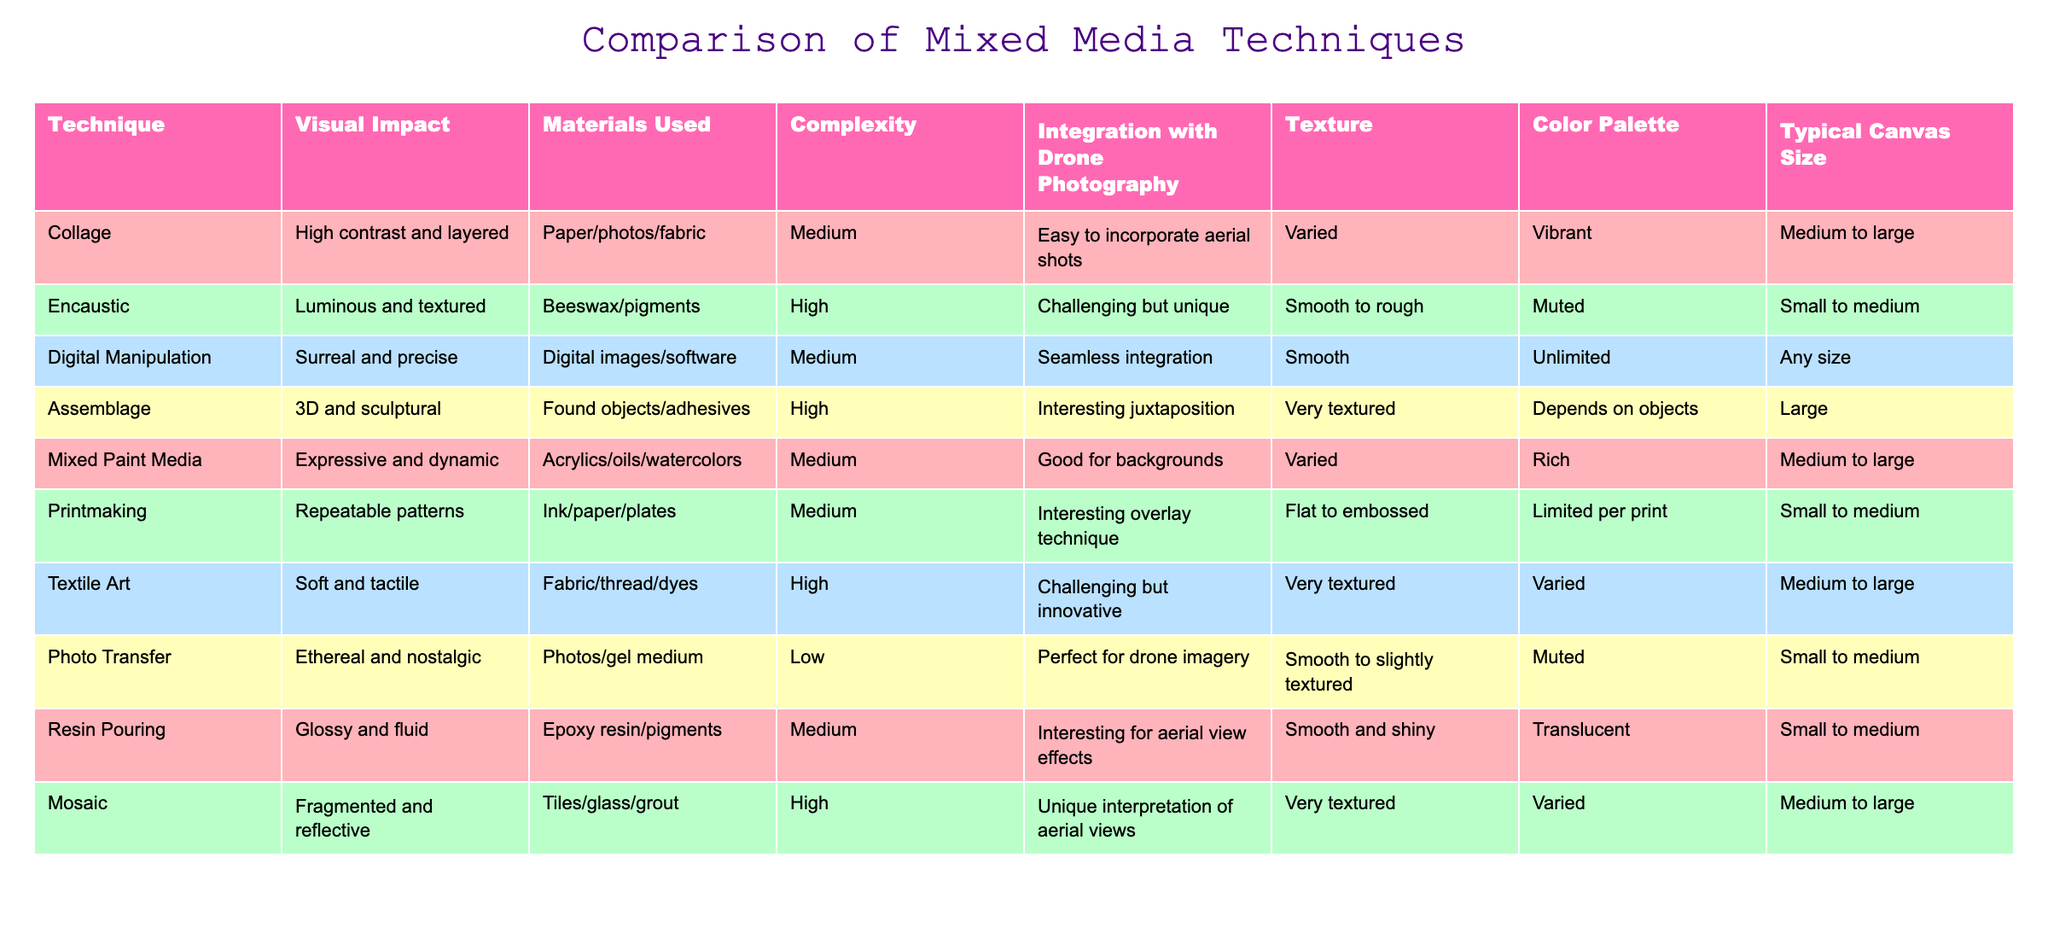What is the complexity level of the Mosaic technique? The table shows the complexity level of each technique. For Mosaic, it is categorized as "High."
Answer: High Which mixed media technique uses digital images and software? The table lists "Digital Manipulation" as the technique that utilizes digital images and software.
Answer: Digital Manipulation How many techniques have a low complexity level? By counting the complexity levels in the table, only the "Photo Transfer" technique is categorized as "Low," making it one technique with this level.
Answer: 1 Is the Textile Art technique easy to integrate with drone photography? The table indicates that Textile Art has a "High" complexity level, suggesting that it is "Challenging but innovative" for drone integration, thus the answer is No.
Answer: No Which two techniques typically have a medium to large canvas size? Referring to the table, "Collage" and "Mixed Paint Media" are noted for having a typical canvas size of medium to large.
Answer: Collage, Mixed Paint Media What is the difference in visual impact between Encaustic and Photo Transfer? Encaustic has a visual impact described as "Luminous and textured," while Photo Transfer has an impact that is "Ethereal and nostalgic." The difference lies in the character of the visual experience they offer.
Answer: Luminous and textured vs. Ethereal and nostalgic How does the texture of Assemblage compare to that of Printmaking? Assemblage is marked as "Very textured," in contrast to Printmaking's description of "Flat to embossed," indicating that Assemblage has a more pronounced texture.
Answer: Assemblage is more textured than Printmaking What is the typical canvas size for Digital Manipulation? The table indicates that the typical canvas size for Digital Manipulation is "Any size," highlighting its flexibility for various formats.
Answer: Any size How many techniques require fabric as a material? The table shows that both "Textile Art" and "Collage" involve fabric as a component; thus, the answer is 2 techniques.
Answer: 2 